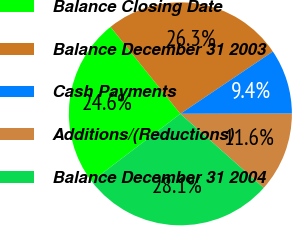Convert chart to OTSL. <chart><loc_0><loc_0><loc_500><loc_500><pie_chart><fcel>Balance Closing Date<fcel>Balance December 31 2003<fcel>Cash Payments<fcel>Additions/(Reductions)<fcel>Balance December 31 2004<nl><fcel>24.6%<fcel>26.34%<fcel>9.41%<fcel>11.58%<fcel>28.08%<nl></chart> 